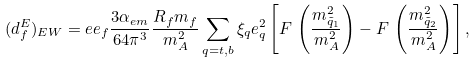Convert formula to latex. <formula><loc_0><loc_0><loc_500><loc_500>( d _ { f } ^ { E } ) _ { E W } = e e _ { f } { \frac { 3 \alpha _ { e m } } { 6 4 \pi ^ { 3 } } } { \frac { R _ { f } m _ { f } } { m _ { A } ^ { 2 } } } \sum _ { q = t , b } \xi _ { q } e _ { q } ^ { 2 } \left [ F \, \left ( { \frac { m _ { \tilde { q } _ { 1 } } ^ { 2 } } { m _ { A } ^ { 2 } } } \right ) - F \, \left ( { \frac { m _ { \tilde { q } _ { 2 } } ^ { 2 } } { m _ { A } ^ { 2 } } } \right ) \right ] ,</formula> 